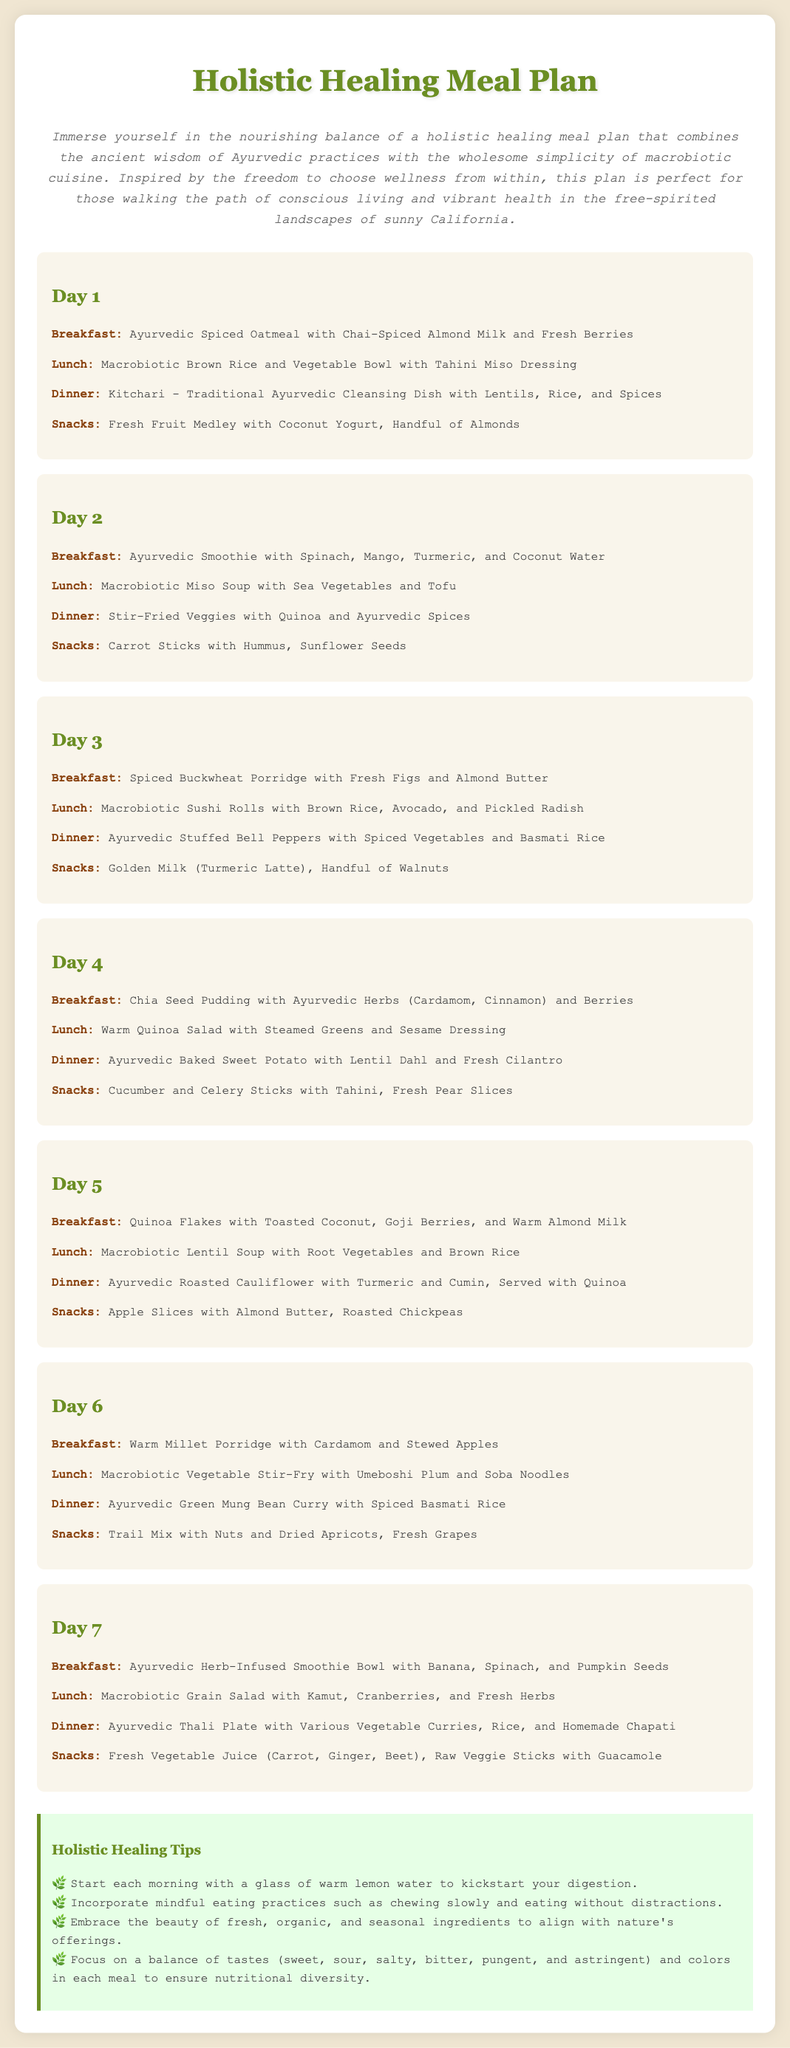What is the title of the meal plan? The title of the meal plan is stated prominently at the top of the document.
Answer: Holistic Healing Meal Plan How many days does the meal plan cover? The document describes a meal plan that spans over a week.
Answer: 7 days What is the breakfast for Day 3? The breakfast for Day 3 is listed under that day's meals.
Answer: Spiced Buckwheat Porridge with Fresh Figs and Almond Butter What meal includes lentils and rice? The meal is specifically mentioned as Kitchari, which consists of lentils and rice, featured on Day 1.
Answer: Dinner What holistic tip encourages mindful eating? One of the tips relates to how one should approach eating for better digestion and wellness.
Answer: Incorporate mindful eating practices such as chewing slowly and eating without distractions Which day features a smoothie? The document lists smoothies for multiple days, specifically in the breakfasts.
Answer: Day 1 and Day 2 What type of cuisine does the meal plan include? The meal plan combines two distinct culinary traditions aimed at holistic health.
Answer: Ayurvedic and Macrobiotic How many snacks are mentioned for Day 4? Snacking options are given under each day's meals, including Day 4's snacks.
Answer: 2 snacks 